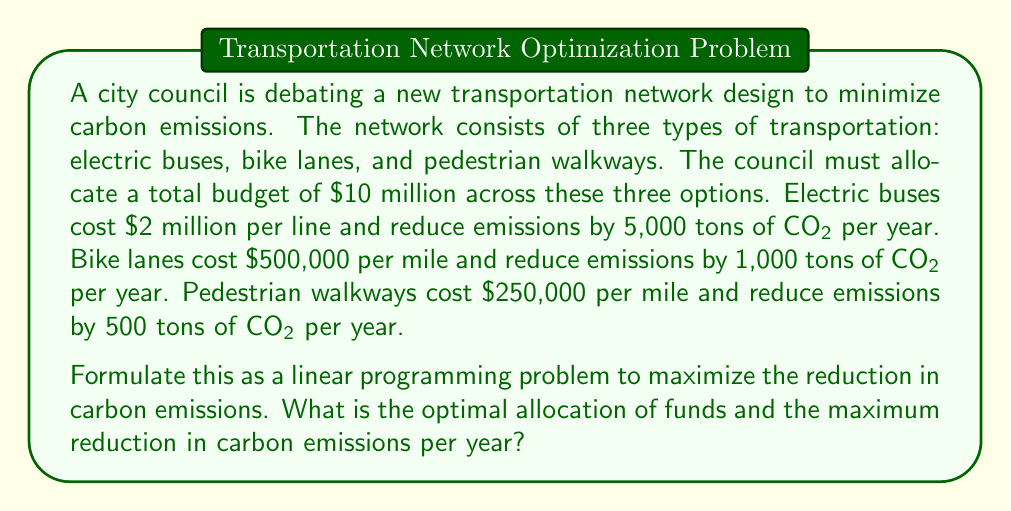Give your solution to this math problem. To formulate this as a linear programming problem, we need to define our variables, objective function, and constraints.

Let:
$x$ = number of electric bus lines
$y$ = miles of bike lanes
$z$ = miles of pedestrian walkways

Objective function (maximize reduction in CO2 emissions):
$$\text{Maximize } 5000x + 1000y + 500z$$

Constraints:
1. Budget constraint: $$2,000,000x + 500,000y + 250,000z \leq 10,000,000$$
2. Non-negativity constraints: $$x, y, z \geq 0$$

To solve this, we can use the simplex method or a graphical method. However, given the nature of the problem, we can also use a greedy approach:

1. First, allocate as much as possible to electric buses (highest CO2 reduction per dollar):
   $10,000,000 \div 2,000,000 = 5$ bus lines
   This uses all $10 million, leaving $0 for other options.

2. Calculate the CO2 reduction:
   $5 \times 5,000 = 25,000$ tons of CO2 per year

Therefore, the optimal solution is to invest all $10 million in electric buses.
Answer: Optimal allocation: 5 electric bus lines, 0 miles of bike lanes, 0 miles of pedestrian walkways.
Maximum reduction in carbon emissions: 25,000 tons of CO2 per year. 